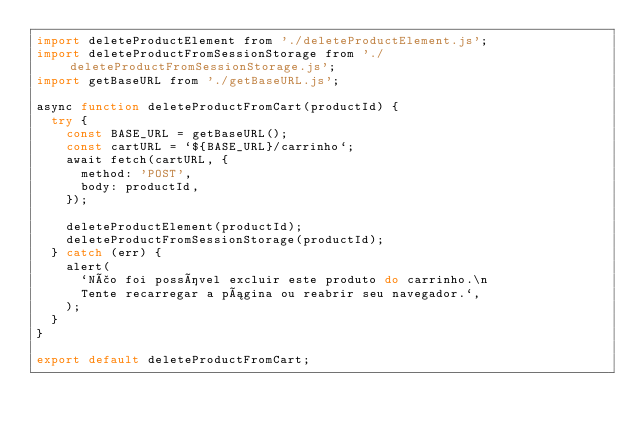Convert code to text. <code><loc_0><loc_0><loc_500><loc_500><_JavaScript_>import deleteProductElement from './deleteProductElement.js';
import deleteProductFromSessionStorage from './deleteProductFromSessionStorage.js';
import getBaseURL from './getBaseURL.js';

async function deleteProductFromCart(productId) {
  try {
    const BASE_URL = getBaseURL();
    const cartURL = `${BASE_URL}/carrinho`;
    await fetch(cartURL, {
      method: 'POST',
      body: productId,
    });

    deleteProductElement(productId);
    deleteProductFromSessionStorage(productId);
  } catch (err) {
    alert(
      `Não foi possível excluir este produto do carrinho.\n
      Tente recarregar a página ou reabrir seu navegador.`,
    );
  }
}

export default deleteProductFromCart;
</code> 